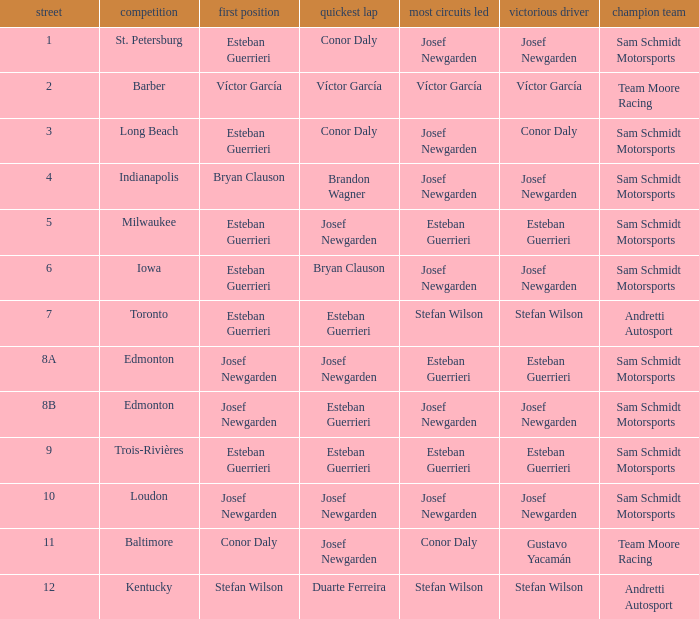Who led the most laps when brandon wagner had the fastest lap? Josef Newgarden. 